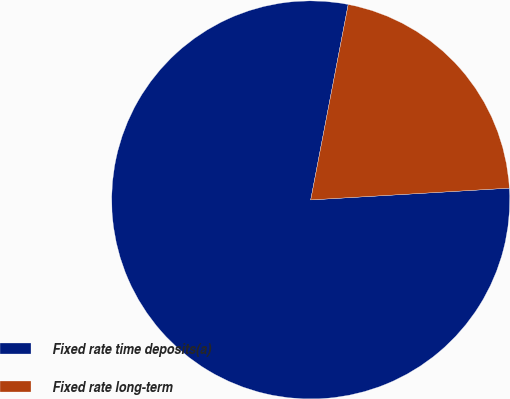<chart> <loc_0><loc_0><loc_500><loc_500><pie_chart><fcel>Fixed rate time deposits(a)<fcel>Fixed rate long-term<nl><fcel>78.96%<fcel>21.04%<nl></chart> 